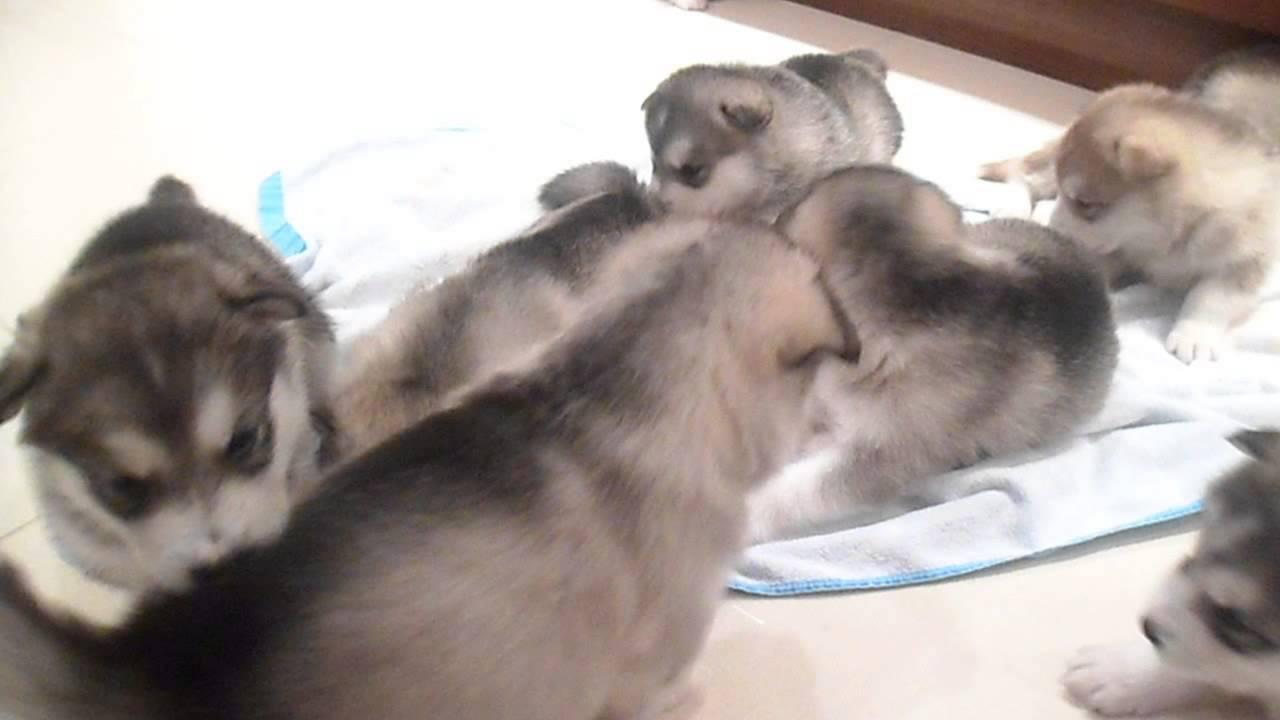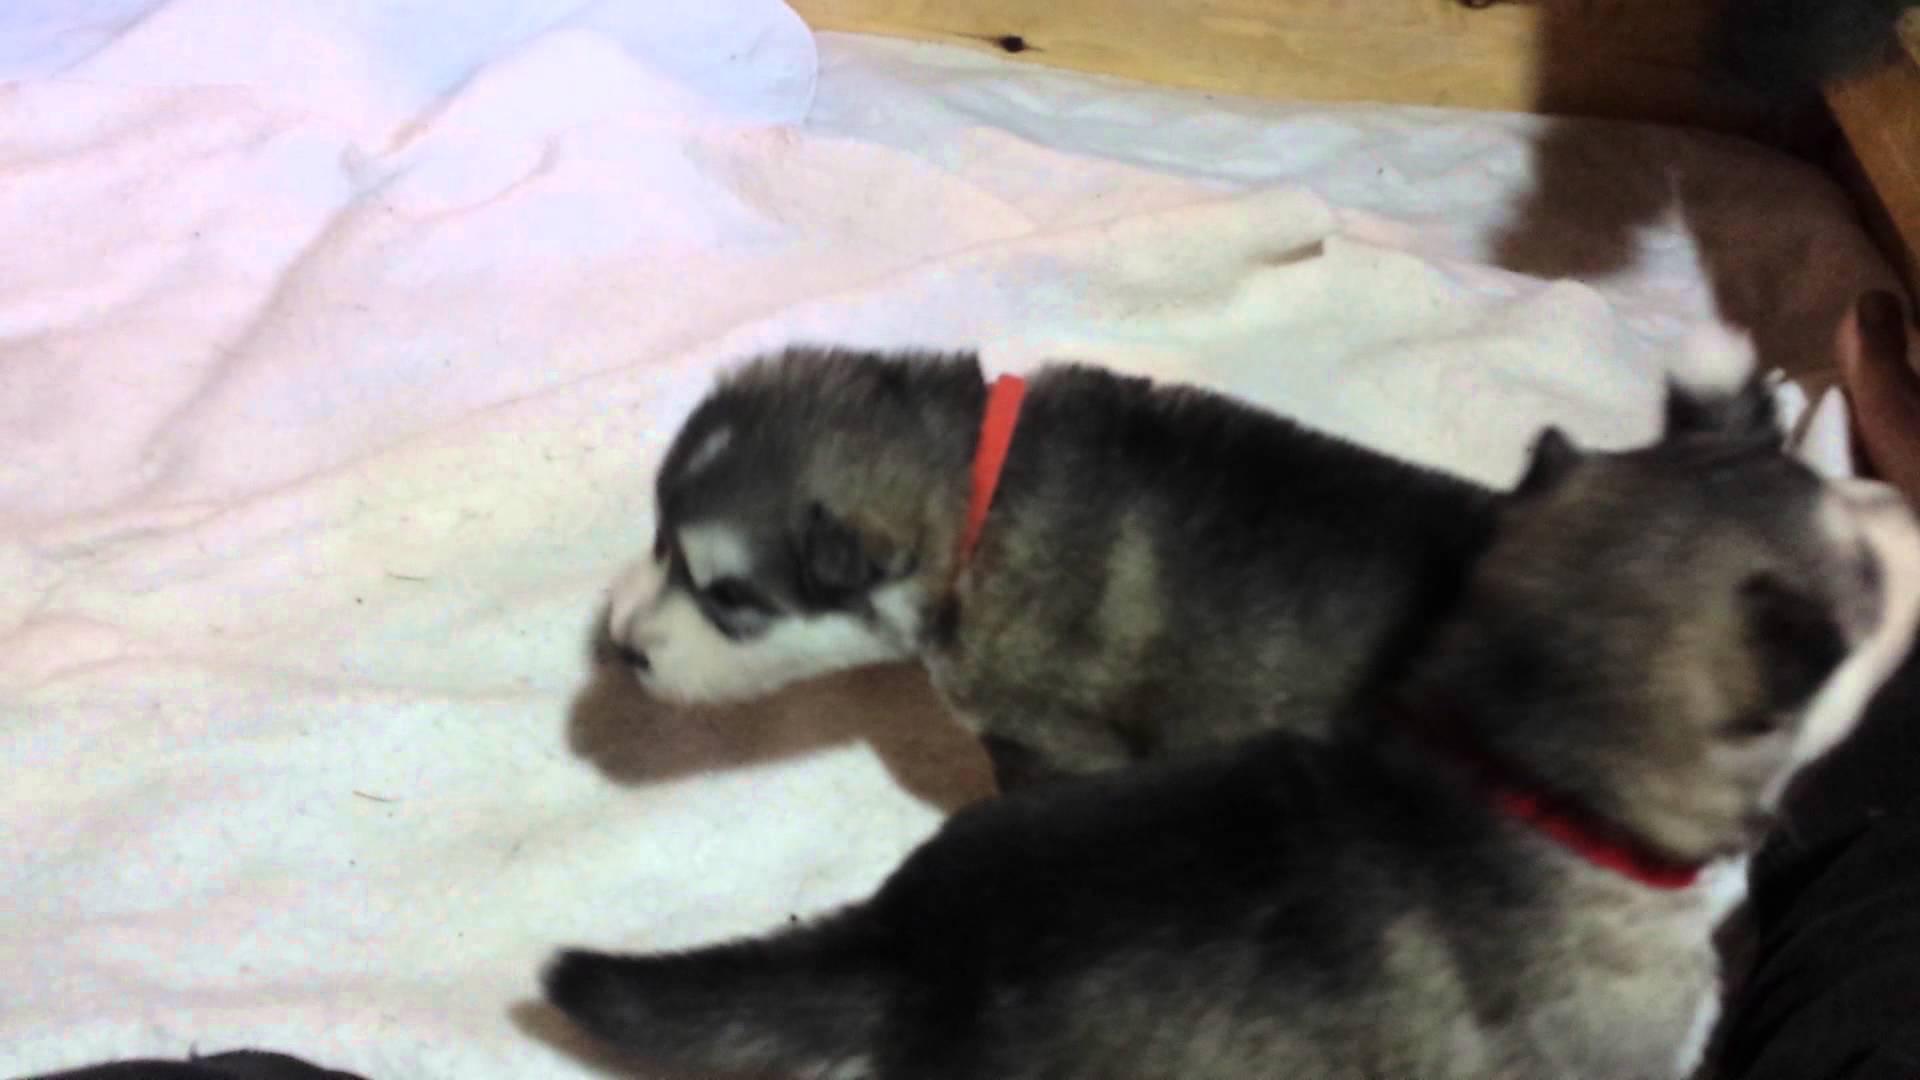The first image is the image on the left, the second image is the image on the right. Considering the images on both sides, is "There are at most 2 puppies in at least one of the images." valid? Answer yes or no. Yes. 